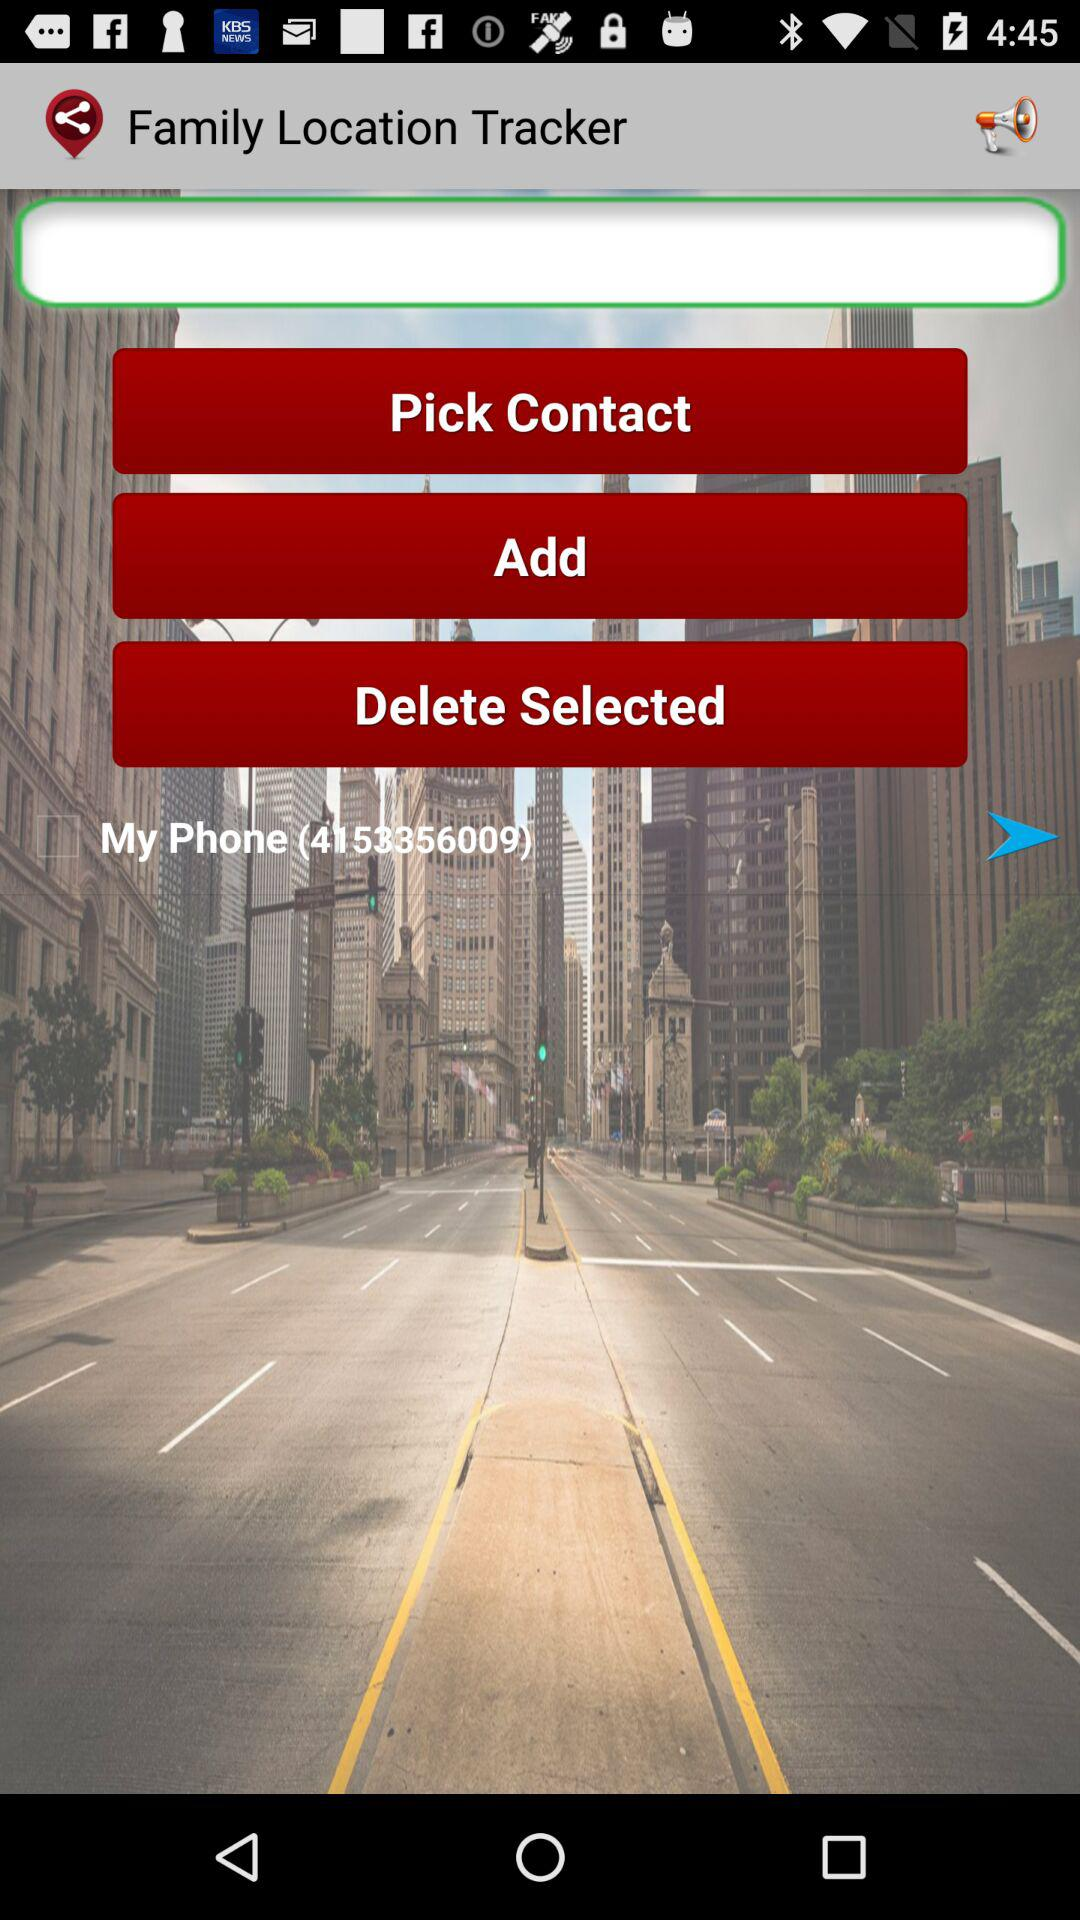What is the phone number shown on the screen? The phone number shown on the screen is 4153356009. 